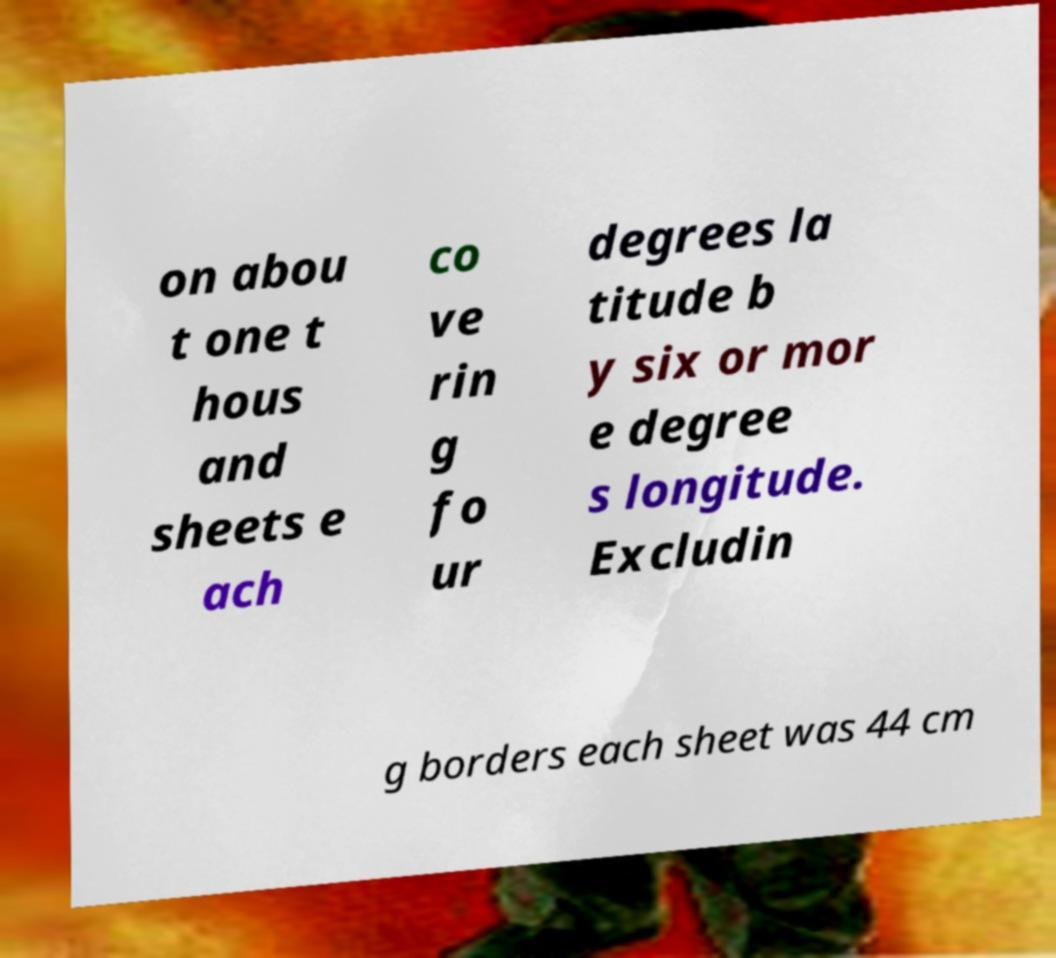I need the written content from this picture converted into text. Can you do that? on abou t one t hous and sheets e ach co ve rin g fo ur degrees la titude b y six or mor e degree s longitude. Excludin g borders each sheet was 44 cm 